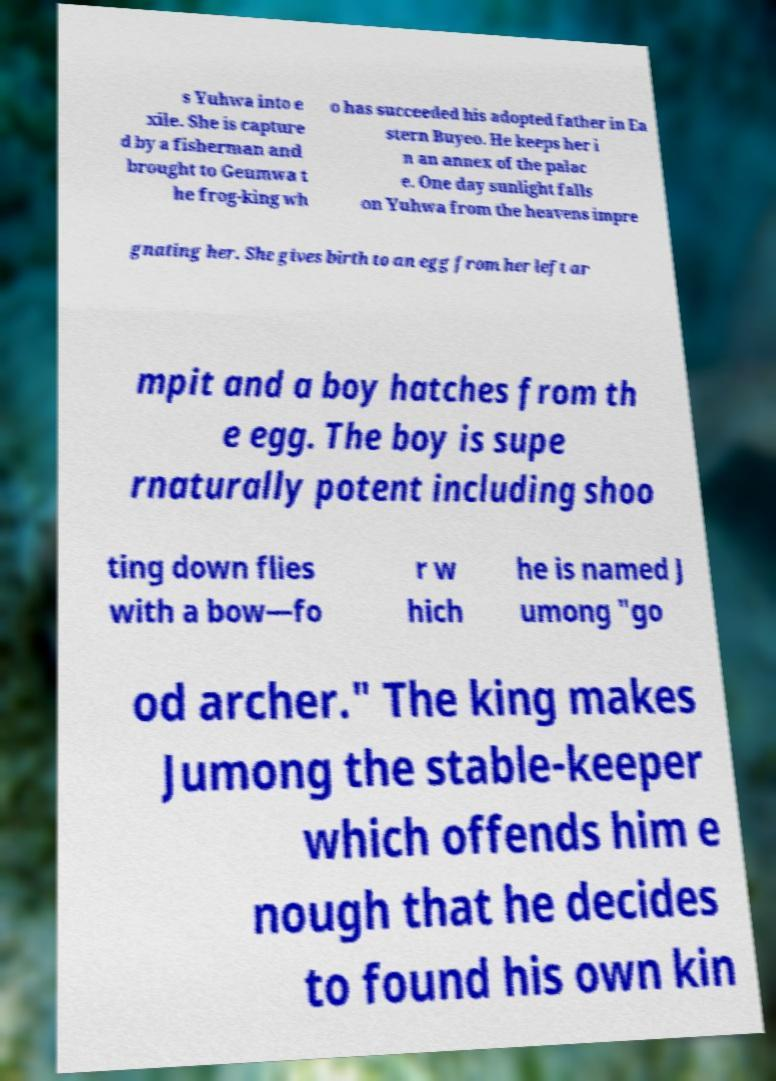What messages or text are displayed in this image? I need them in a readable, typed format. s Yuhwa into e xile. She is capture d by a fisherman and brought to Geumwa t he frog-king wh o has succeeded his adopted father in Ea stern Buyeo. He keeps her i n an annex of the palac e. One day sunlight falls on Yuhwa from the heavens impre gnating her. She gives birth to an egg from her left ar mpit and a boy hatches from th e egg. The boy is supe rnaturally potent including shoo ting down flies with a bow—fo r w hich he is named J umong "go od archer." The king makes Jumong the stable-keeper which offends him e nough that he decides to found his own kin 